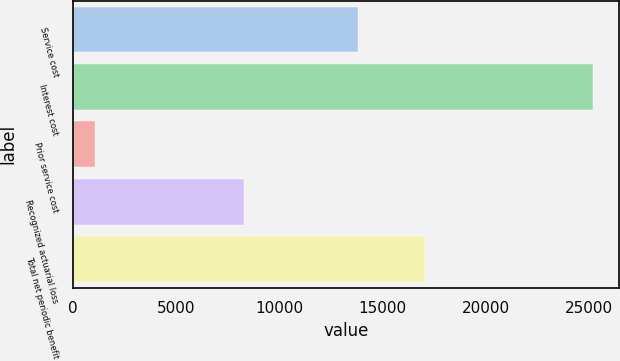<chart> <loc_0><loc_0><loc_500><loc_500><bar_chart><fcel>Service cost<fcel>Interest cost<fcel>Prior service cost<fcel>Recognized actuarial loss<fcel>Total net periodic benefit<nl><fcel>13801<fcel>25204<fcel>1083<fcel>8289<fcel>17062<nl></chart> 